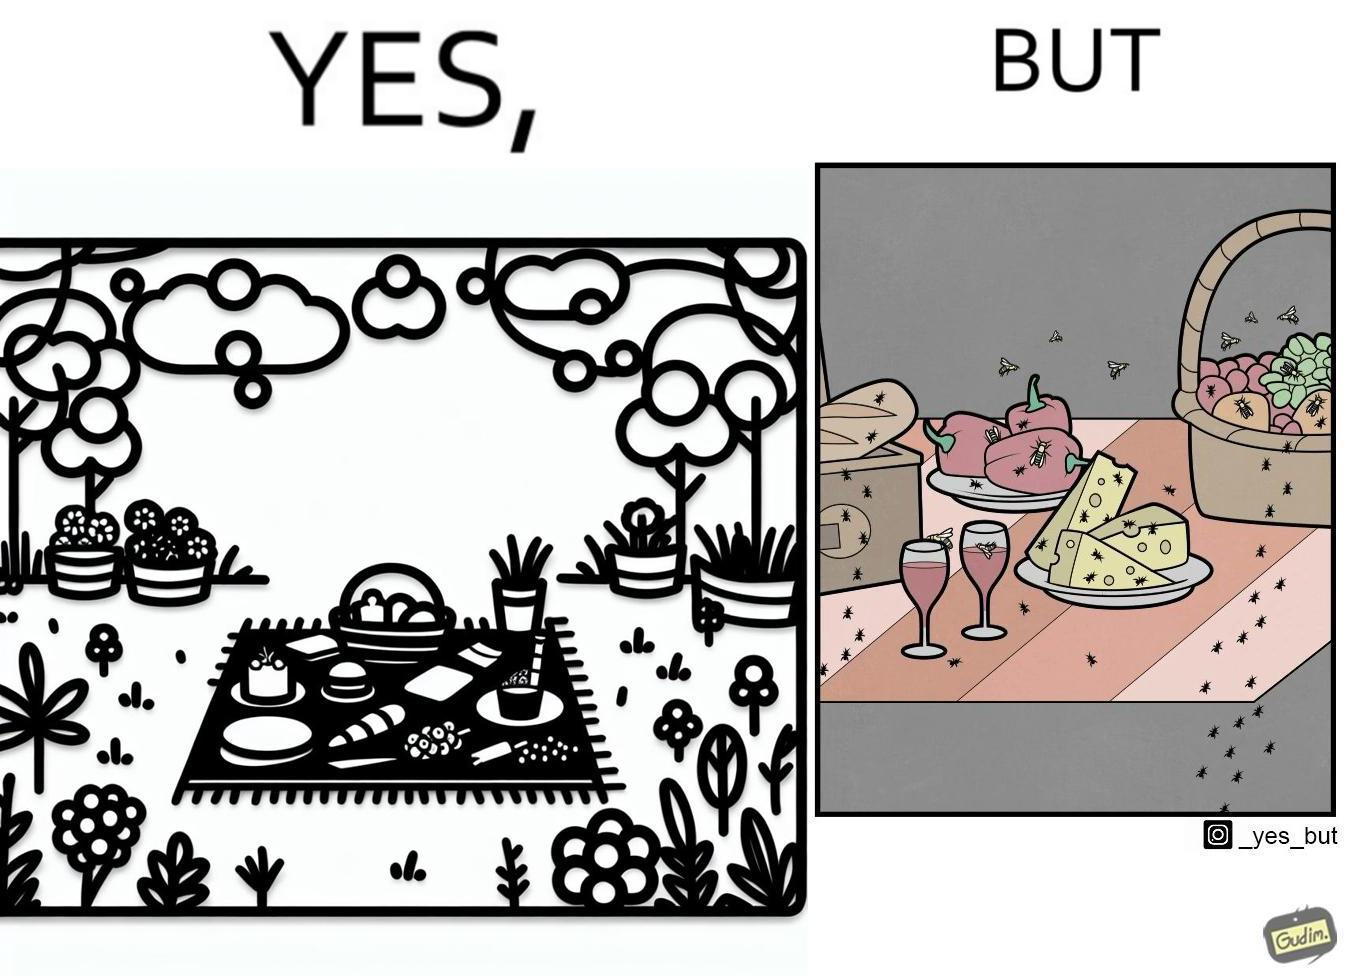What makes this image funny or satirical? The Picture shows that although we enjoy food in garden but there are some consequences of eating food in garden. Many bugs and bees are attracted towards our food and make our food sometimes non-eatable. 